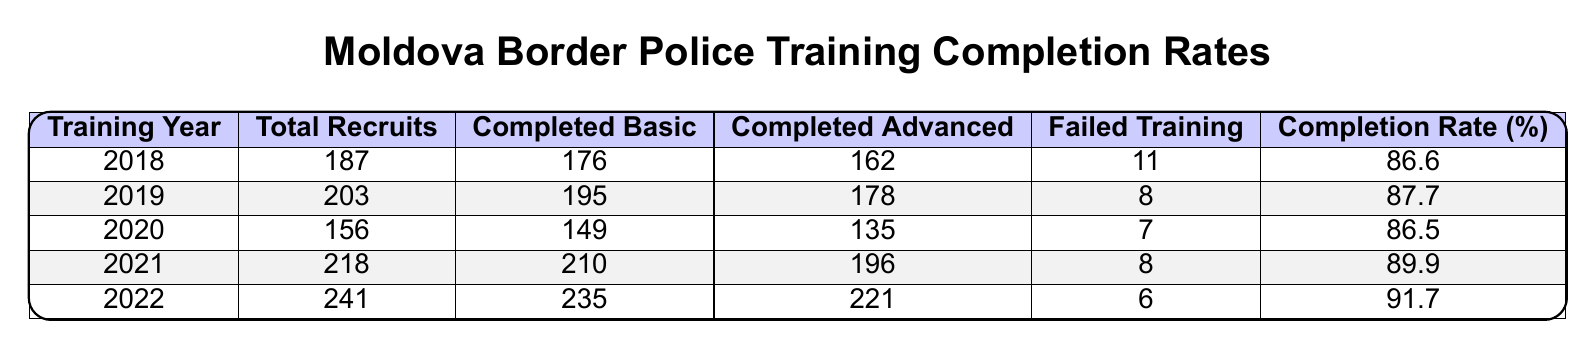What was the Completion Rate for 2020? The Completion Rate for 2020 can be directly retrieved from the table, which shows it as 86.5%.
Answer: 86.5% How many recruits failed training in 2022? The table specifies that the number of recruits who failed training in 2022 was 6.
Answer: 6 What is the total number of recruits who completed Advanced Training in 2019 and 2021 combined? The number of recruits who completed Advanced Training in 2019 is 178 and in 2021 is 196. Adding these gives 178 + 196 = 374.
Answer: 374 Did the Completion Rate increase from 2018 to 2022? By comparing the Completion Rates: 2018 (86.6%) and 2022 (91.7%), we see that 91.7% is greater than 86.6%, confirming an increase.
Answer: Yes Which year had the highest number of Total Recruits, and what was that number? The year 2022 had the highest number of Total Recruits, which was 241. This can be identified by comparing the Total Recruits across all years in the table.
Answer: 241 What is the average Completion Rate from 2018 to 2022? To find the average Completion Rate, sum the Completion Rates of each year (86.6 + 87.7 + 86.5 + 89.9 + 91.7) = 442.4 and divide by 5, giving 442.4 / 5 = 88.48.
Answer: 88.48 How many total recruits completed Basic Training across all years? Summing the completed Basic Training numbers: 176 + 195 + 149 + 210 + 235 = 1065 provides the total recruits who completed Basic Training.
Answer: 1065 What was the difference in Completion Rate between 2019 and 2020? The Completion Rate for 2019 is 87.7% and for 2020 is 86.5%. The difference is 87.7 - 86.5 = 1.2%.
Answer: 1.2% Which year had the lowest Completion Rate and what was it? The lowest Completion Rate can be determined from the table: 2020 had a Completion Rate of 86.5%, which is the least compared to other years.
Answer: 86.5% How many recruits failed training over the five years? The total number of failed trainings can be calculated by adding failed trainings for each year: 11 + 8 + 7 + 8 + 6 = 40.
Answer: 40 Is it true that more than 90% of recruits completed Advanced Training in 2022? The Completion Rate for Advanced Training in 2022 is 91.7%, which is indeed greater than 90%, so the statement is true.
Answer: Yes 